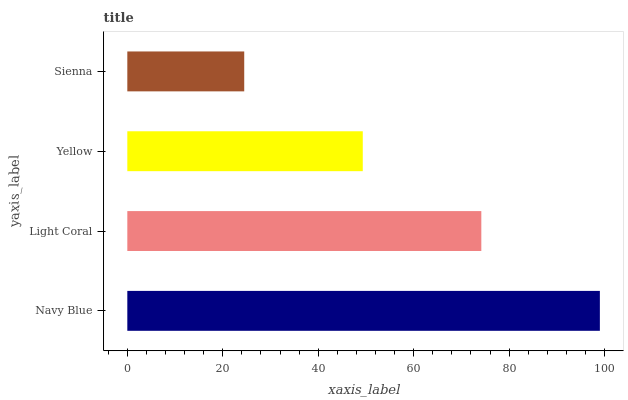Is Sienna the minimum?
Answer yes or no. Yes. Is Navy Blue the maximum?
Answer yes or no. Yes. Is Light Coral the minimum?
Answer yes or no. No. Is Light Coral the maximum?
Answer yes or no. No. Is Navy Blue greater than Light Coral?
Answer yes or no. Yes. Is Light Coral less than Navy Blue?
Answer yes or no. Yes. Is Light Coral greater than Navy Blue?
Answer yes or no. No. Is Navy Blue less than Light Coral?
Answer yes or no. No. Is Light Coral the high median?
Answer yes or no. Yes. Is Yellow the low median?
Answer yes or no. Yes. Is Navy Blue the high median?
Answer yes or no. No. Is Navy Blue the low median?
Answer yes or no. No. 